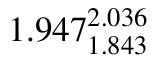Convert formula to latex. <formula><loc_0><loc_0><loc_500><loc_500>1 . 9 4 7 _ { 1 . 8 4 3 } ^ { 2 . 0 3 6 }</formula> 